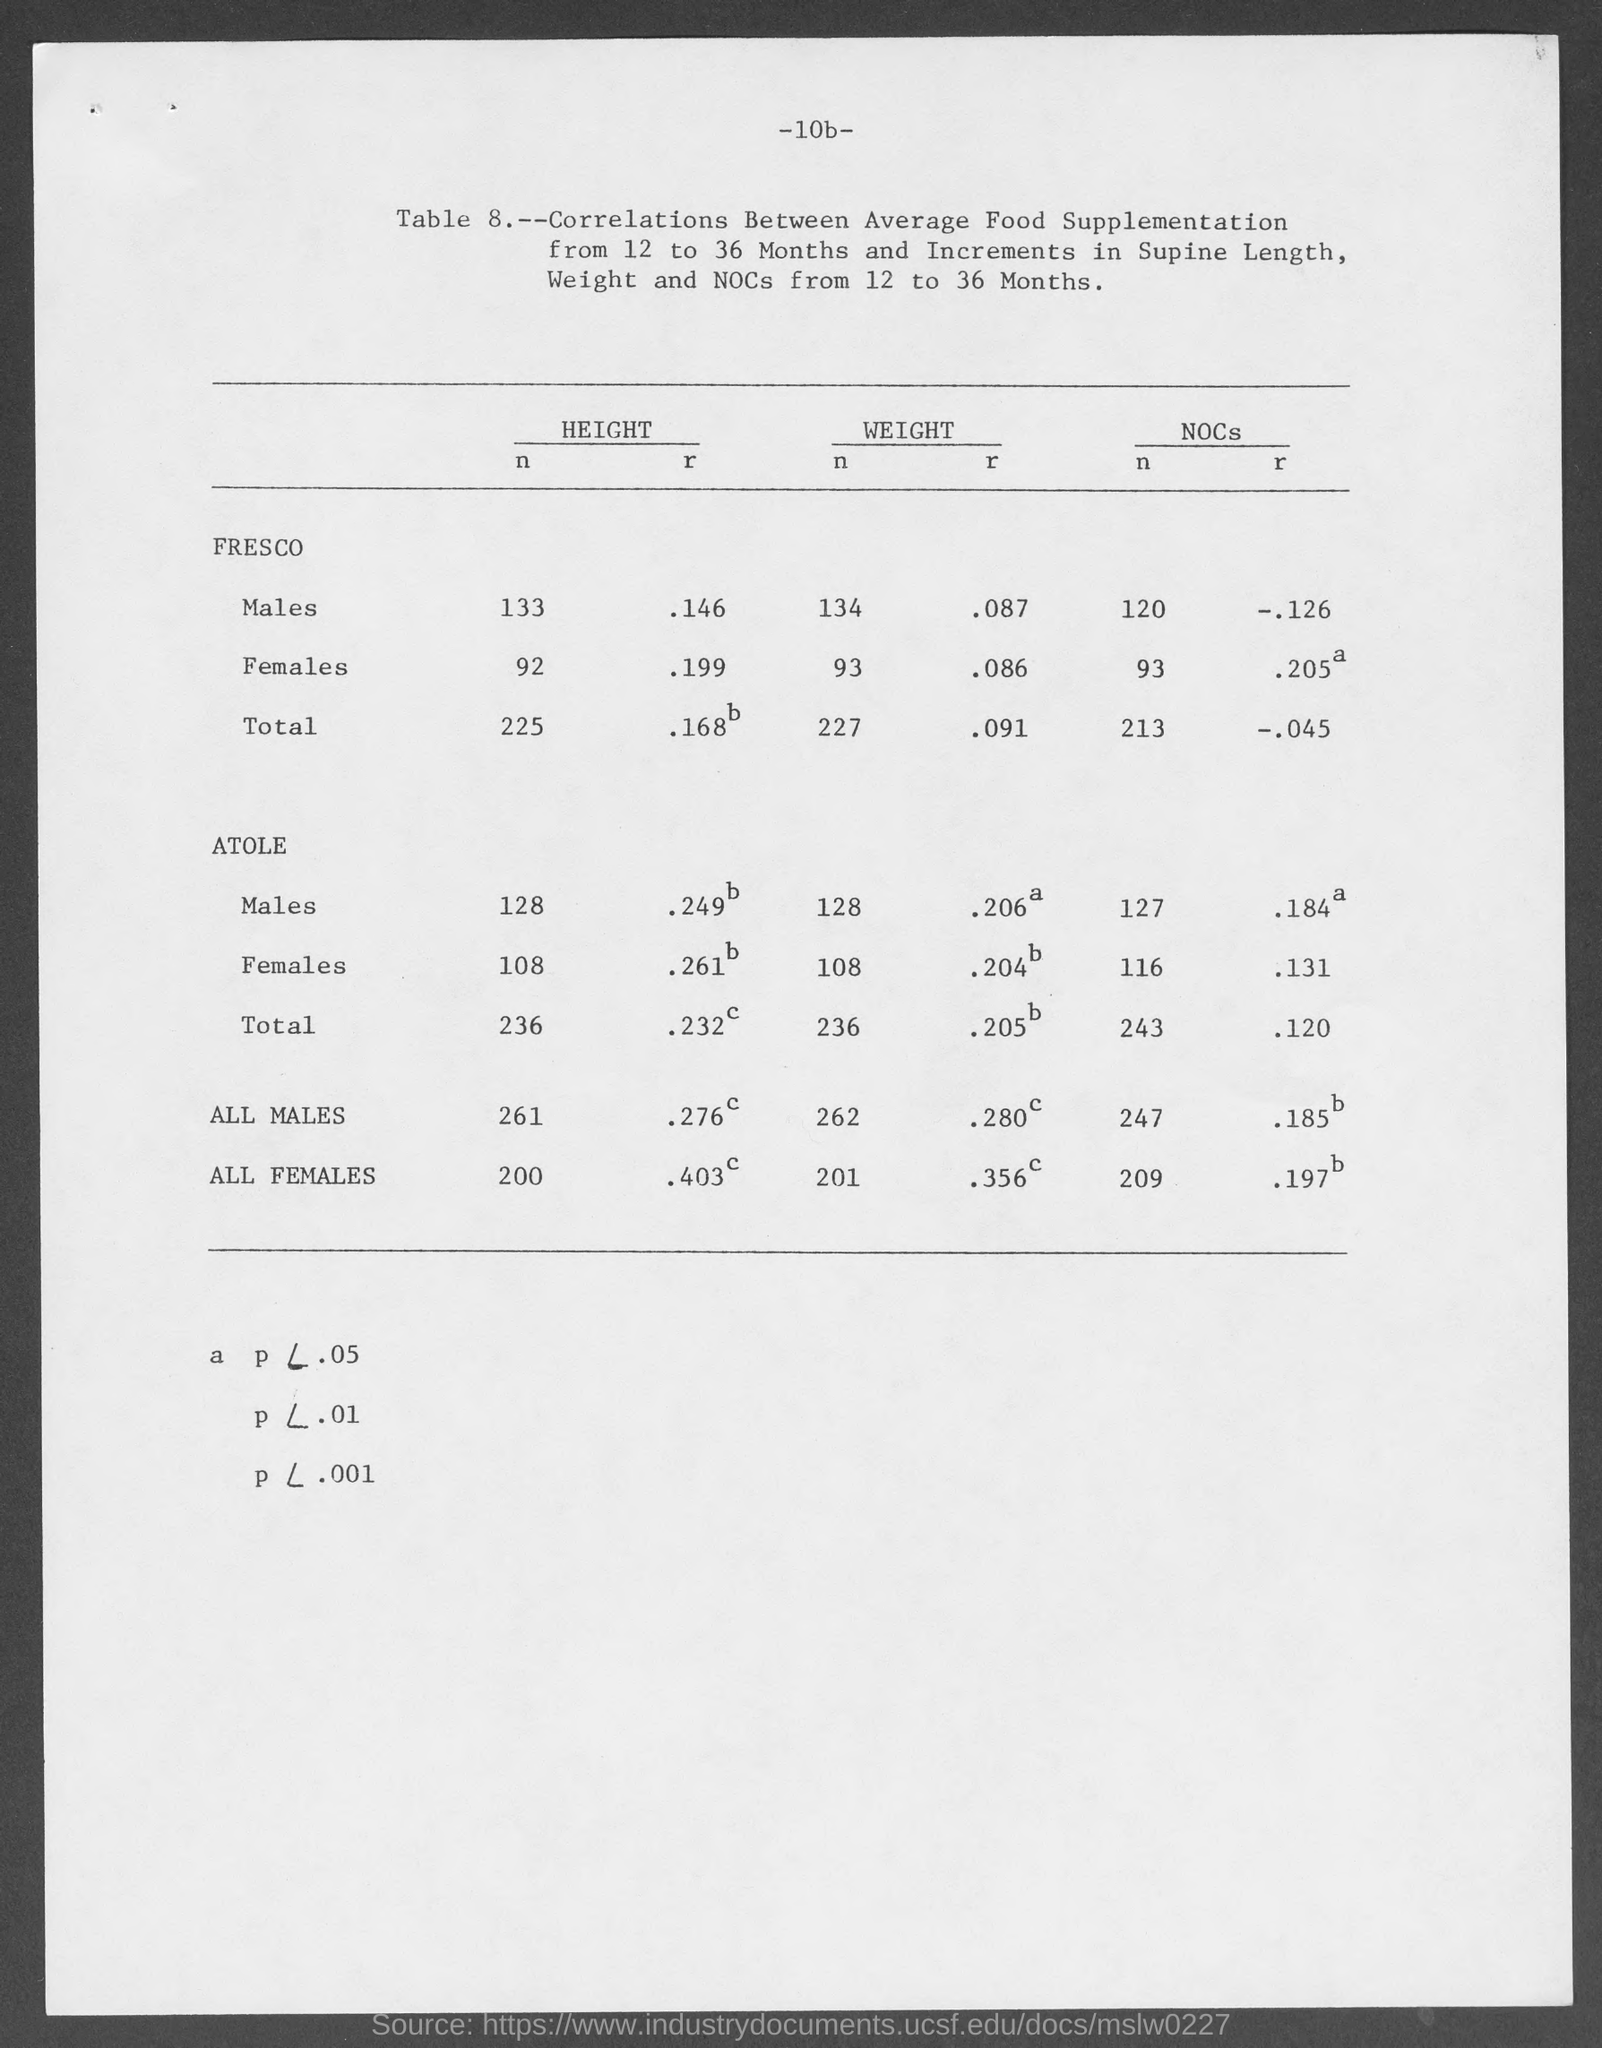What is the weight of n for males in fresco as mentioned in the given page ?
Give a very brief answer. 134. What is the weight of r for males in fresco as mentioned in the given page ?
Keep it short and to the point. .087. What is the weight of n for females in fresco as mentioned in the given page ?
Offer a very short reply. 93. What is the weight of r for females in fresco as mentioned in the given page ?
Make the answer very short. .086. What is the height of n for females in fresco as mentioned in the given page ?
Keep it short and to the point. 92. What is the height of n for males in fresco as mentioned in the given page ?
Your response must be concise. 133. What is the height of r for males in fresco as mentioned in the given page ?
Make the answer very short. .146. What is the height of r for females in fresco as mentioned in the given page ?
Provide a short and direct response. .199. What is the height of n for males in atole as mentioned in the given page ?
Your answer should be very brief. 128. What is the height of n for females in atole as mentioned in the given page ?
Offer a very short reply. 108. 